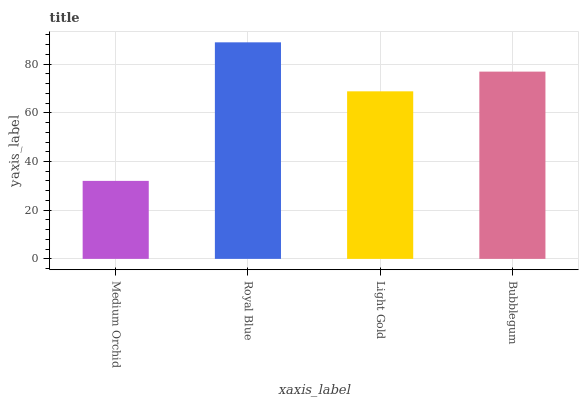Is Medium Orchid the minimum?
Answer yes or no. Yes. Is Royal Blue the maximum?
Answer yes or no. Yes. Is Light Gold the minimum?
Answer yes or no. No. Is Light Gold the maximum?
Answer yes or no. No. Is Royal Blue greater than Light Gold?
Answer yes or no. Yes. Is Light Gold less than Royal Blue?
Answer yes or no. Yes. Is Light Gold greater than Royal Blue?
Answer yes or no. No. Is Royal Blue less than Light Gold?
Answer yes or no. No. Is Bubblegum the high median?
Answer yes or no. Yes. Is Light Gold the low median?
Answer yes or no. Yes. Is Light Gold the high median?
Answer yes or no. No. Is Royal Blue the low median?
Answer yes or no. No. 